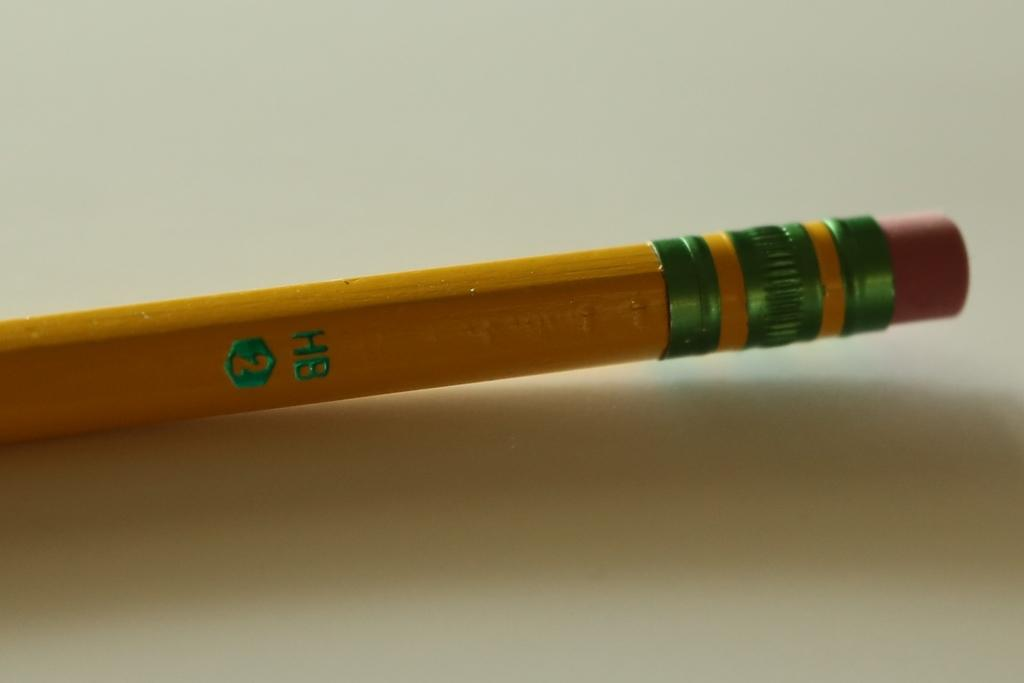<image>
Write a terse but informative summary of the picture. The standard yellow pencil with eraser is made by HB and has a #2 lead. 